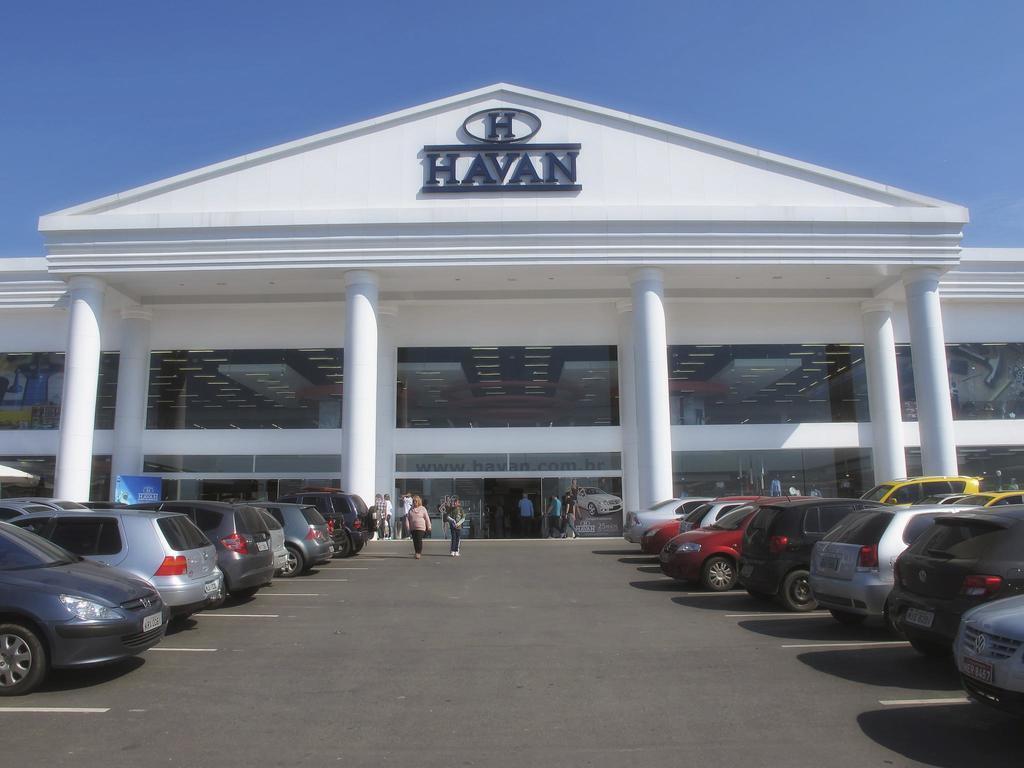In one or two sentences, can you explain what this image depicts? In the middle it's a big building, few persons are walking on this road and many vehicles are parked. 